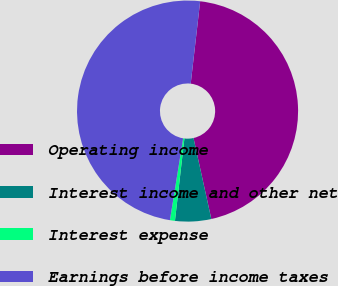Convert chart to OTSL. <chart><loc_0><loc_0><loc_500><loc_500><pie_chart><fcel>Operating income<fcel>Interest income and other net<fcel>Interest expense<fcel>Earnings before income taxes<nl><fcel>44.73%<fcel>5.27%<fcel>0.73%<fcel>49.27%<nl></chart> 